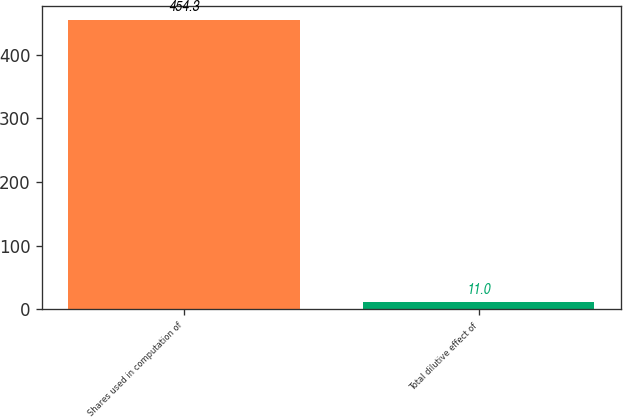Convert chart to OTSL. <chart><loc_0><loc_0><loc_500><loc_500><bar_chart><fcel>Shares used in computation of<fcel>Total dilutive effect of<nl><fcel>454.3<fcel>11<nl></chart> 